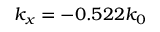Convert formula to latex. <formula><loc_0><loc_0><loc_500><loc_500>k _ { x } = - 0 . 5 2 2 k _ { 0 }</formula> 